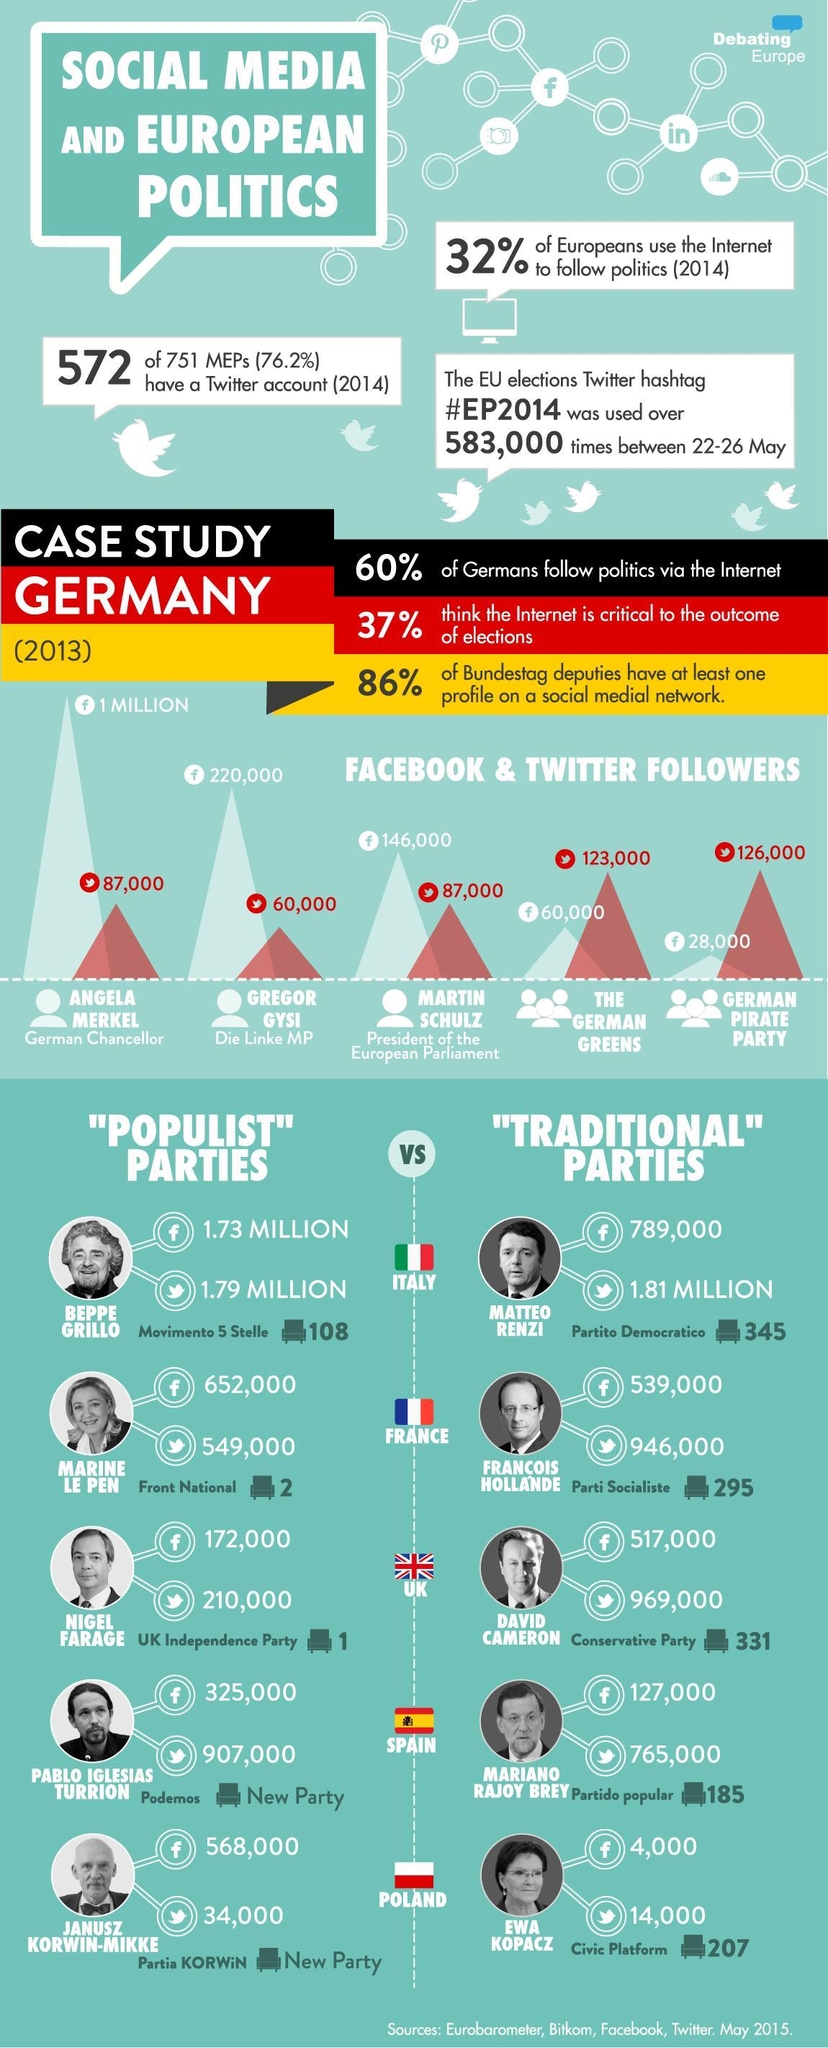Who was the German Chancellor in 2013?
Answer the question with a short phrase. ANGELA MERKEL How many people followed Marine Le Pen on Facebook as of May 2015? 652,000 In which political party does David Cameron belong to? Conservative Party How many twitter followers were there for the German pirate party in 2013? 126,000 How many people followed the German Greens party on Facebook in 2013? 60,000 Which Italian politician had the most number of Twitter followers as of May 2015? MATTEO RENZI Who was the President of the European Parliament in 2013? MARTIN SCHULZ 